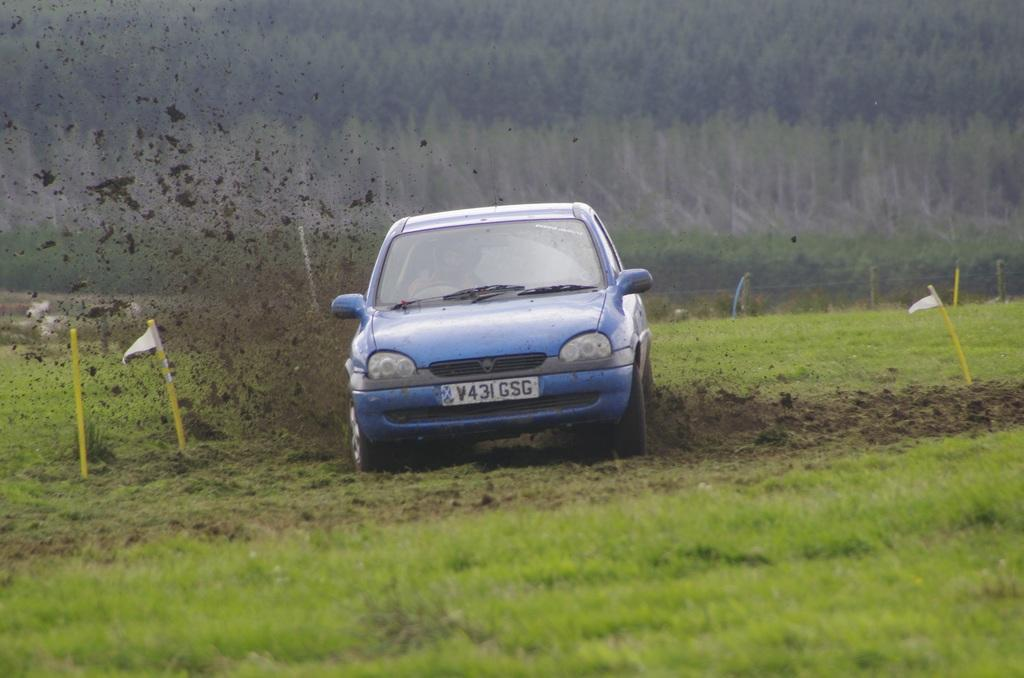What is the main subject of the image? There is a car in the image. What is the condition of the ground around the car? Sand is dispersed around the car. What type of vegetation is present in the image? The land is covered with grass. What can be seen in the background of the image? There are many trees in the background of the image. What type of cloth is draped over the yak in the image? There is no yak present in the image, and therefore no cloth draped over it. Can you tell me how many maps are visible in the image? There are no maps visible in the image. 